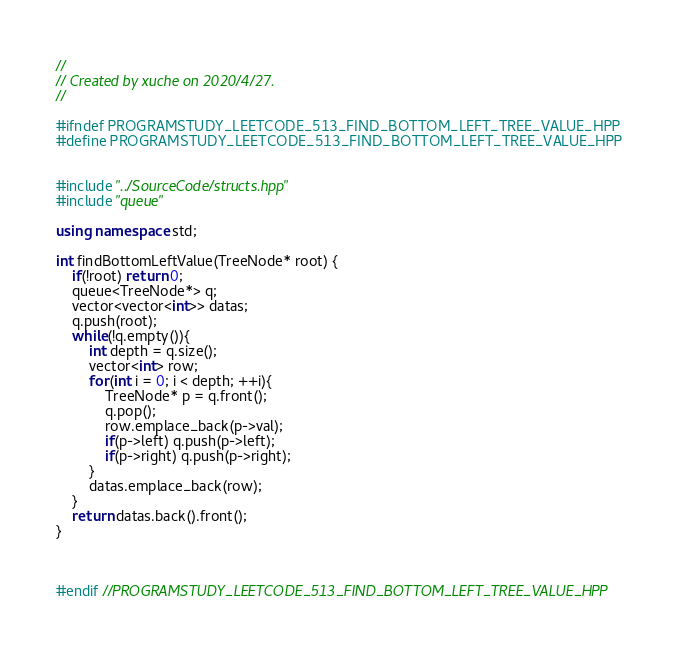<code> <loc_0><loc_0><loc_500><loc_500><_C++_>//
// Created by xuche on 2020/4/27.
//

#ifndef PROGRAMSTUDY_LEETCODE_513_FIND_BOTTOM_LEFT_TREE_VALUE_HPP
#define PROGRAMSTUDY_LEETCODE_513_FIND_BOTTOM_LEFT_TREE_VALUE_HPP


#include "../SourceCode/structs.hpp"
#include "queue"

using namespace std;

int findBottomLeftValue(TreeNode* root) {
    if(!root) return 0;
    queue<TreeNode*> q;
    vector<vector<int>> datas;
    q.push(root);
    while(!q.empty()){
        int depth = q.size();
        vector<int> row;
        for(int i = 0; i < depth; ++i){
            TreeNode* p = q.front();
            q.pop();
            row.emplace_back(p->val);
            if(p->left) q.push(p->left);
            if(p->right) q.push(p->right);
        }
        datas.emplace_back(row);
    }
    return datas.back().front();
}



#endif //PROGRAMSTUDY_LEETCODE_513_FIND_BOTTOM_LEFT_TREE_VALUE_HPP
</code> 